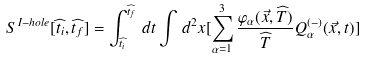<formula> <loc_0><loc_0><loc_500><loc_500>S ^ { I - h o l e } [ \widehat { t _ { i } } , \widehat { t _ { f } } ] = \int _ { \widehat { t _ { i } } } ^ { \widehat { t _ { f } } } \, d t \int \, d ^ { 2 } x [ \sum _ { \alpha = 1 } ^ { 3 } \frac { \varphi _ { \alpha } ( \vec { x } , \widehat { T } ) } { \widehat { T } } Q ^ { ( - ) } _ { \alpha } ( \vec { x } , t ) ]</formula> 